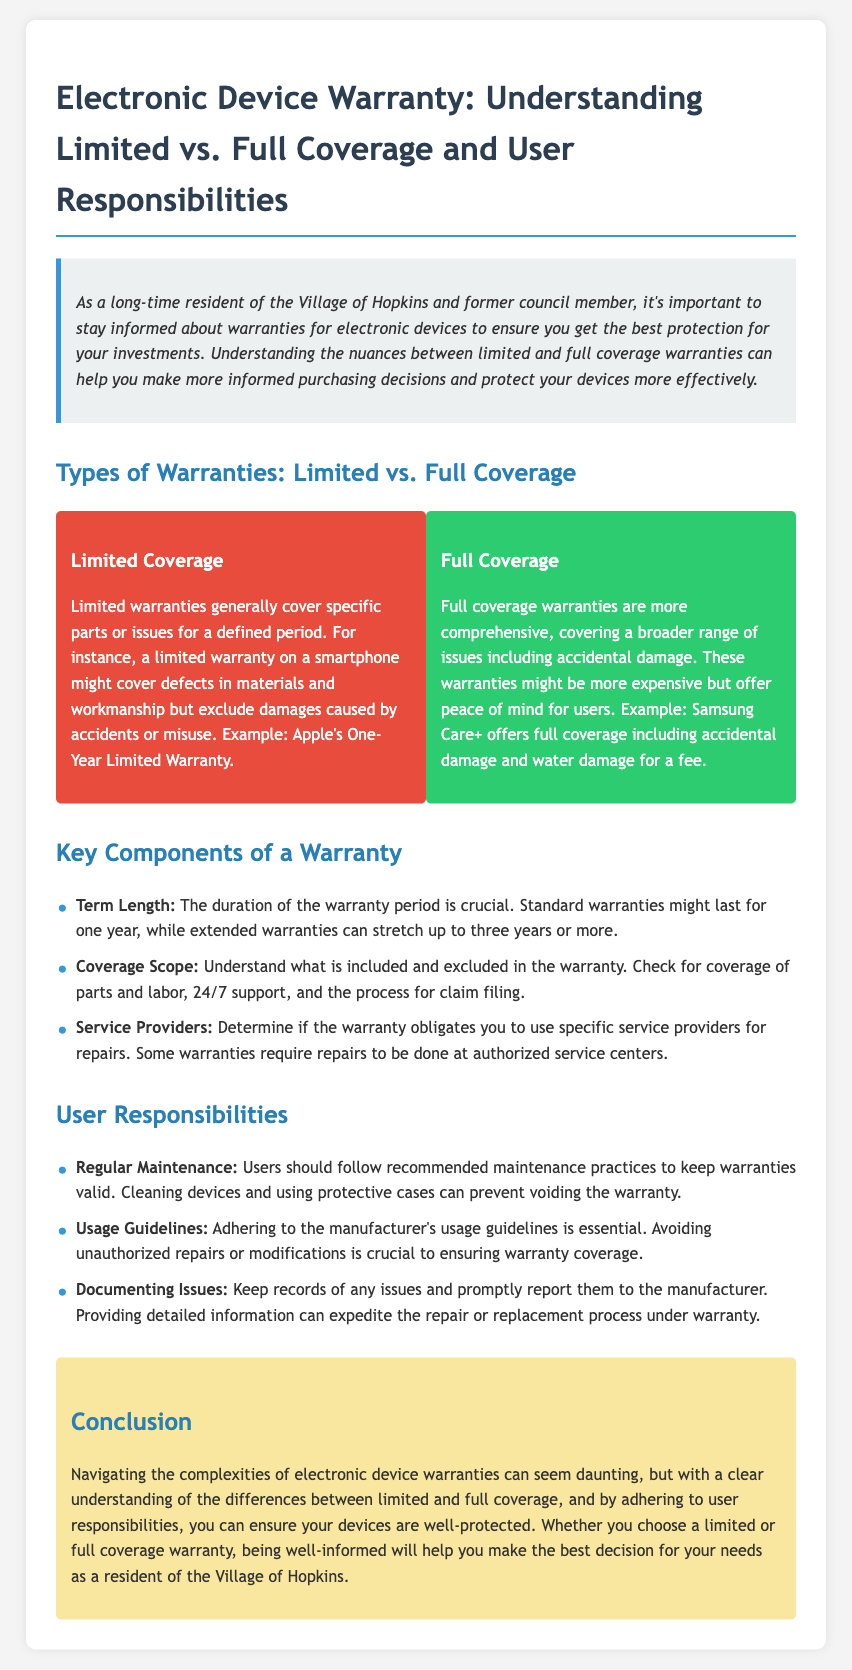What is the title of the document? The title is provided in the h1 tag of the document, which is the main heading.
Answer: Electronic Device Warranty: Understanding Limited vs. Full Coverage and User Responsibilities What does a limited warranty typically cover? The document states that limited warranties usually cover specific parts or issues but not damages caused by accidents or misuse.
Answer: Defects in materials and workmanship What is an example of a full coverage warranty? An example of full coverage mentioned in the document is provided in the context of a specific service.
Answer: Samsung Care+ How long might standard warranties last? The document mentions the duration of warranties in relation to typical industry standards for electronic devices.
Answer: One year What should users maintain to keep warranties valid? The document advises on best practices for maintaining warranty coverage, specifically what actions users should take.
Answer: Regular maintenance What is a key component of a warranty regarding repairs? The document indicates that some warranties may impose restrictions on where repairs can be done.
Answer: Service providers What should be documented to expedite the warranty process? The document highlights the importance of having records for a specific purpose when making warranty claims.
Answer: Issues Why might full coverage warranties be more expensive? The document implies a reason why users might incur additional costs for certain types of warranties.
Answer: They cover a broader range of issues What is an example of user responsibility for device usage? The document discusses what users must adhere to in order to maintain warranty validity.
Answer: Usage guidelines 